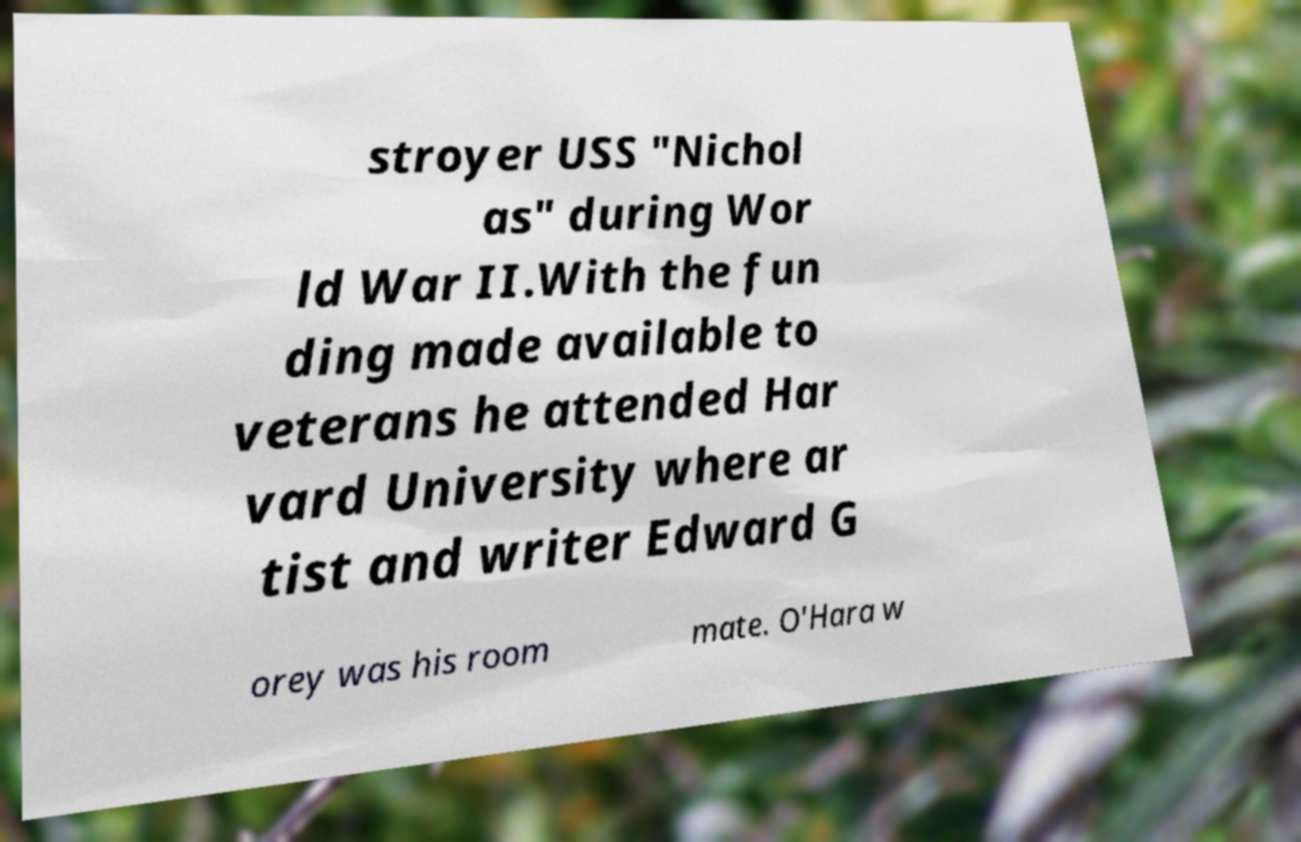Please identify and transcribe the text found in this image. stroyer USS "Nichol as" during Wor ld War II.With the fun ding made available to veterans he attended Har vard University where ar tist and writer Edward G orey was his room mate. O'Hara w 